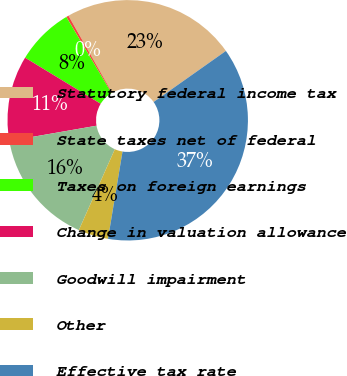Convert chart. <chart><loc_0><loc_0><loc_500><loc_500><pie_chart><fcel>Statutory federal income tax<fcel>State taxes net of federal<fcel>Taxes on foreign earnings<fcel>Change in valuation allowance<fcel>Goodwill impairment<fcel>Other<fcel>Effective tax rate<nl><fcel>23.42%<fcel>0.33%<fcel>7.75%<fcel>11.46%<fcel>15.59%<fcel>4.04%<fcel>37.41%<nl></chart> 